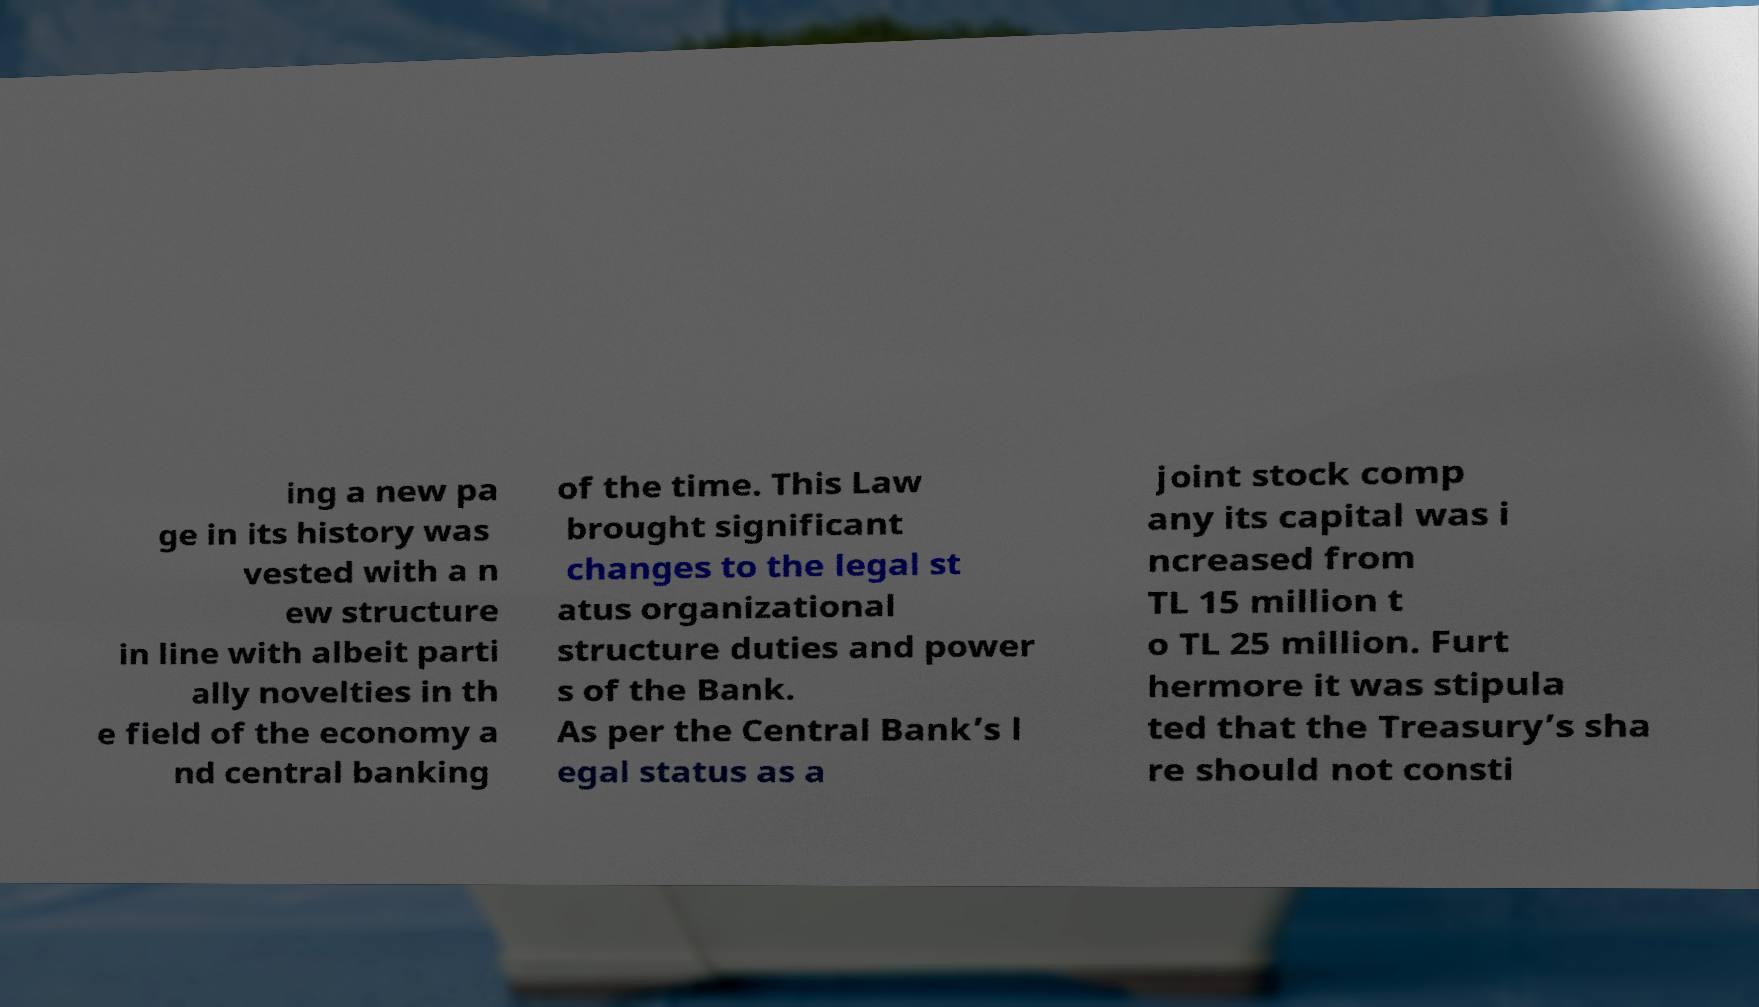Please read and relay the text visible in this image. What does it say? ing a new pa ge in its history was vested with a n ew structure in line with albeit parti ally novelties in th e field of the economy a nd central banking of the time. This Law brought significant changes to the legal st atus organizational structure duties and power s of the Bank. As per the Central Bank’s l egal status as a joint stock comp any its capital was i ncreased from TL 15 million t o TL 25 million. Furt hermore it was stipula ted that the Treasury’s sha re should not consti 